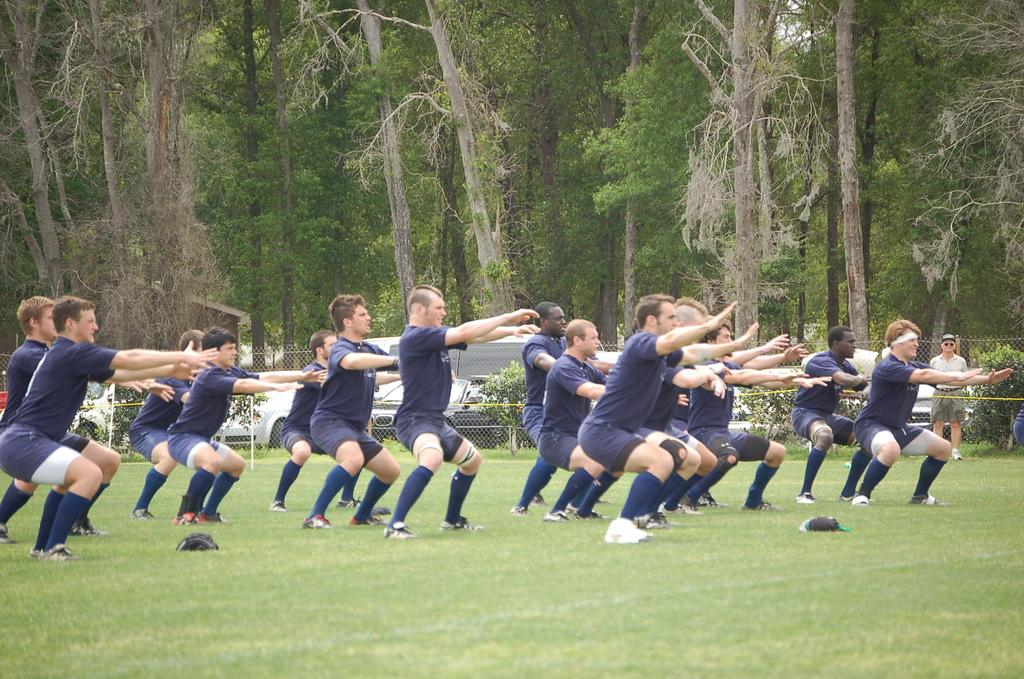What are the men in the image doing? The men in the image are doing exercise. What else can be seen in the image besides the men exercising? There are plants, motor vehicles, fences, and trees visible in the image. What type of trick is the man performing on the tree in the image? There is no man performing a trick on a tree in the image; the image only shows men exercising and other elements mentioned earlier. 